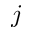Convert formula to latex. <formula><loc_0><loc_0><loc_500><loc_500>j</formula> 